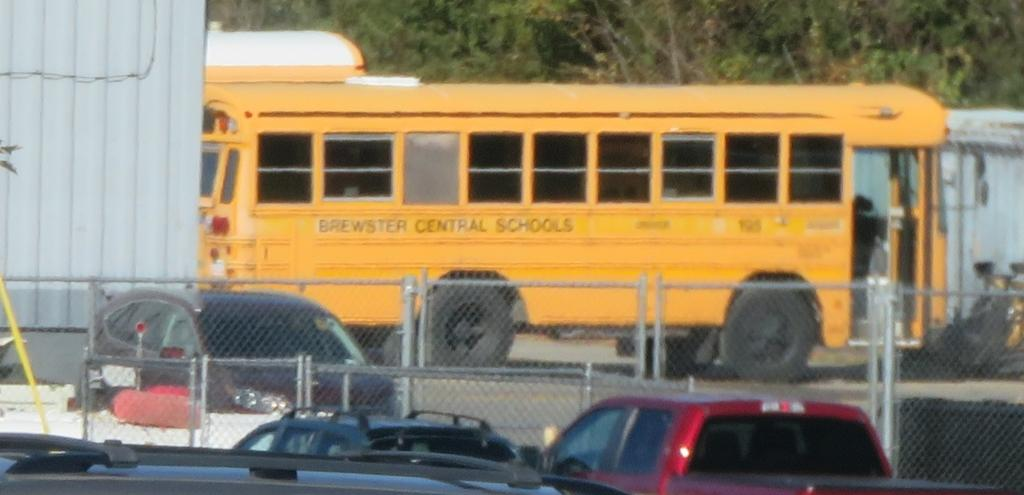<image>
Describe the image concisely. A Brewster Central school bus is parked with the door open. 